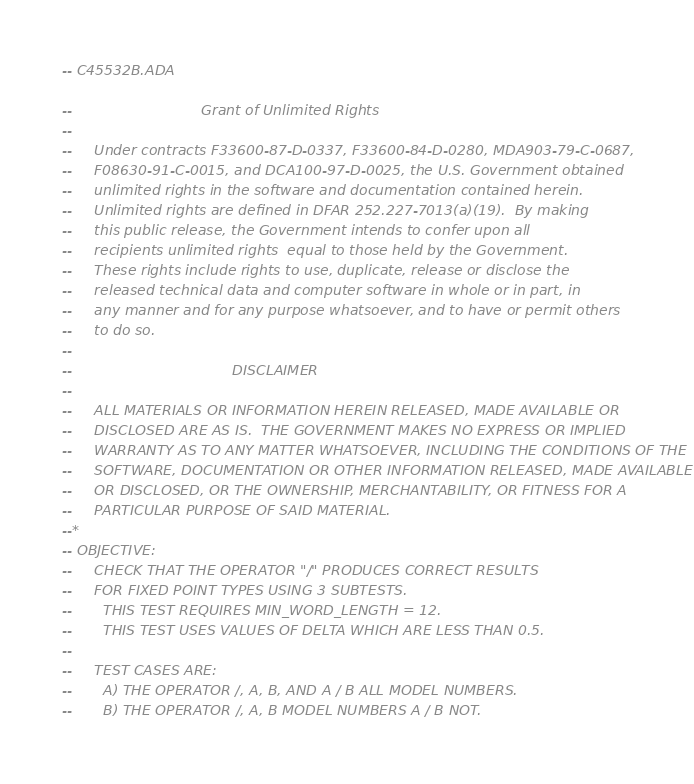<code> <loc_0><loc_0><loc_500><loc_500><_Ada_>-- C45532B.ADA

--                             Grant of Unlimited Rights
--
--     Under contracts F33600-87-D-0337, F33600-84-D-0280, MDA903-79-C-0687,
--     F08630-91-C-0015, and DCA100-97-D-0025, the U.S. Government obtained 
--     unlimited rights in the software and documentation contained herein.
--     Unlimited rights are defined in DFAR 252.227-7013(a)(19).  By making 
--     this public release, the Government intends to confer upon all 
--     recipients unlimited rights  equal to those held by the Government.  
--     These rights include rights to use, duplicate, release or disclose the 
--     released technical data and computer software in whole or in part, in 
--     any manner and for any purpose whatsoever, and to have or permit others 
--     to do so.
--
--                                    DISCLAIMER
--
--     ALL MATERIALS OR INFORMATION HEREIN RELEASED, MADE AVAILABLE OR
--     DISCLOSED ARE AS IS.  THE GOVERNMENT MAKES NO EXPRESS OR IMPLIED 
--     WARRANTY AS TO ANY MATTER WHATSOEVER, INCLUDING THE CONDITIONS OF THE
--     SOFTWARE, DOCUMENTATION OR OTHER INFORMATION RELEASED, MADE AVAILABLE 
--     OR DISCLOSED, OR THE OWNERSHIP, MERCHANTABILITY, OR FITNESS FOR A
--     PARTICULAR PURPOSE OF SAID MATERIAL.
--*
-- OBJECTIVE:
--     CHECK THAT THE OPERATOR "/" PRODUCES CORRECT RESULTS
--     FOR FIXED POINT TYPES USING 3 SUBTESTS.
--       THIS TEST REQUIRES MIN_WORD_LENGTH = 12.
--       THIS TEST USES VALUES OF DELTA WHICH ARE LESS THAN 0.5.
--
--     TEST CASES ARE:
--       A) THE OPERATOR /, A, B, AND A / B ALL MODEL NUMBERS.
--       B) THE OPERATOR /, A, B MODEL NUMBERS A / B NOT.</code> 